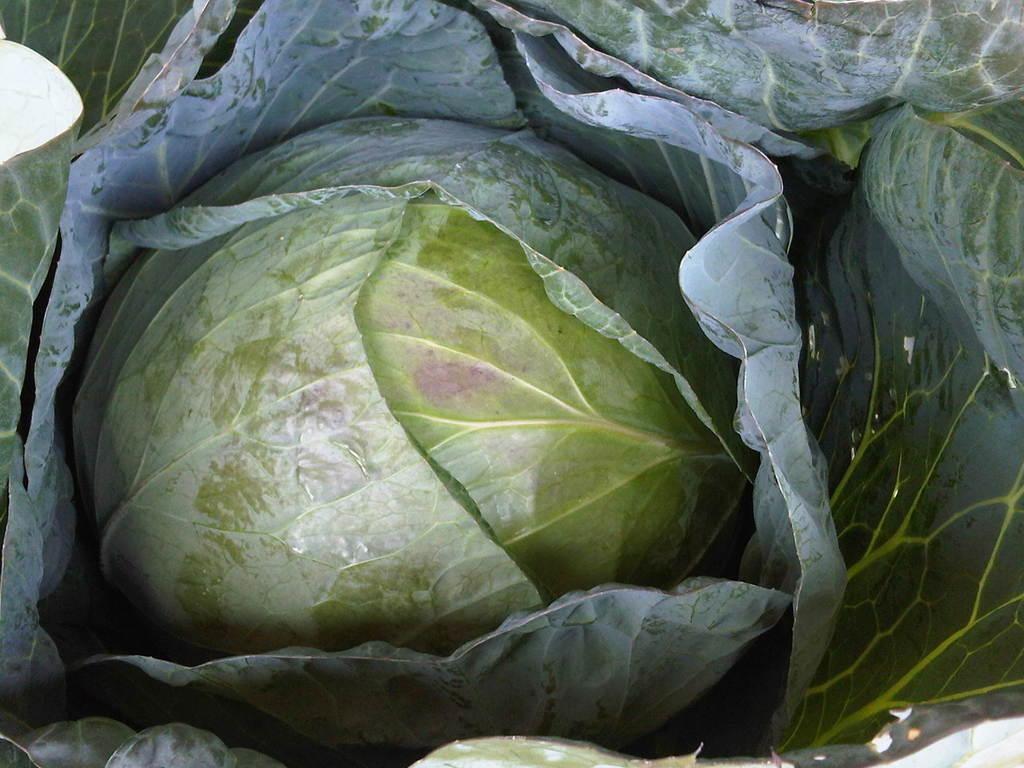In one or two sentences, can you explain what this image depicts? In this image, we can see a cabbage. Here we can see green leaves. 